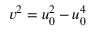<formula> <loc_0><loc_0><loc_500><loc_500>v ^ { 2 } = u _ { 0 } ^ { 2 } - u _ { 0 } ^ { 4 }</formula> 